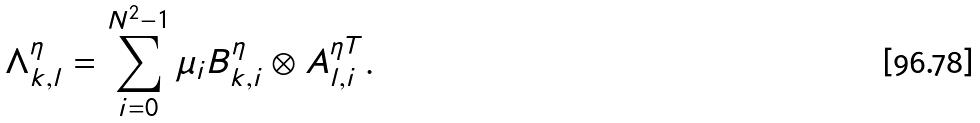Convert formula to latex. <formula><loc_0><loc_0><loc_500><loc_500>\Lambda ^ { \eta } _ { k , l } = \sum _ { i = 0 } ^ { N ^ { 2 } - 1 } \mu _ { i } B _ { k , i } ^ { \eta } \otimes A ^ { \eta T } _ { l , i } .</formula> 